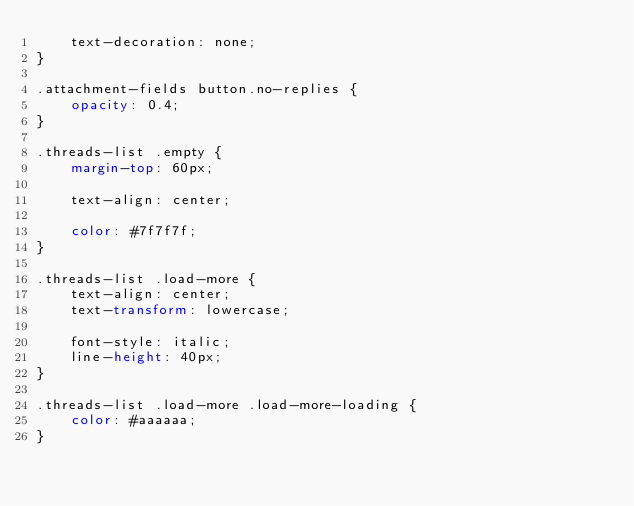<code> <loc_0><loc_0><loc_500><loc_500><_CSS_>	text-decoration: none;
}

.attachment-fields button.no-replies {
	opacity: 0.4;
}

.threads-list .empty {
	margin-top: 60px;

	text-align: center;

	color: #7f7f7f;
}

.threads-list .load-more {
	text-align: center;
	text-transform: lowercase;

	font-style: italic;
	line-height: 40px;
}

.threads-list .load-more .load-more-loading {
	color: #aaaaaa;
}
</code> 